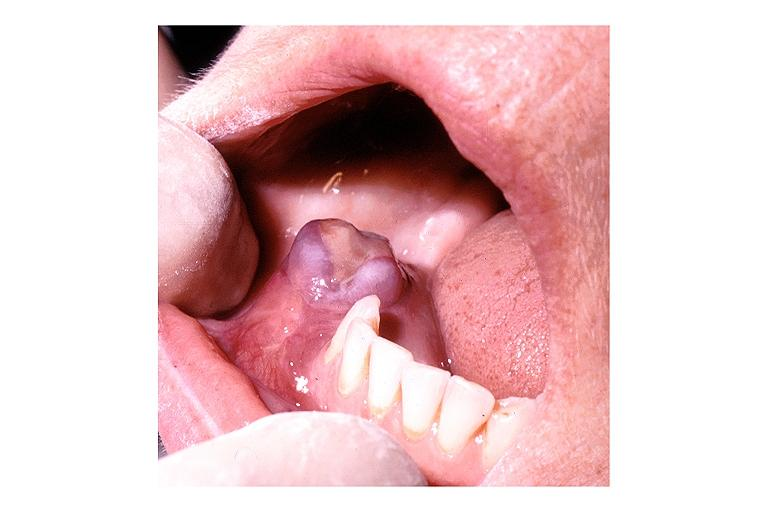does purulent sinusitis show hyperparathyroidism brown tumor?
Answer the question using a single word or phrase. No 